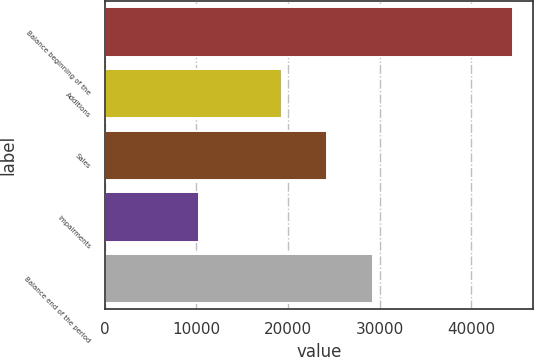Convert chart. <chart><loc_0><loc_0><loc_500><loc_500><bar_chart><fcel>Balance beginning of the<fcel>Additions<fcel>Sales<fcel>Impairments<fcel>Balance end of the period<nl><fcel>44533<fcel>19341<fcel>24308<fcel>10314<fcel>29252<nl></chart> 